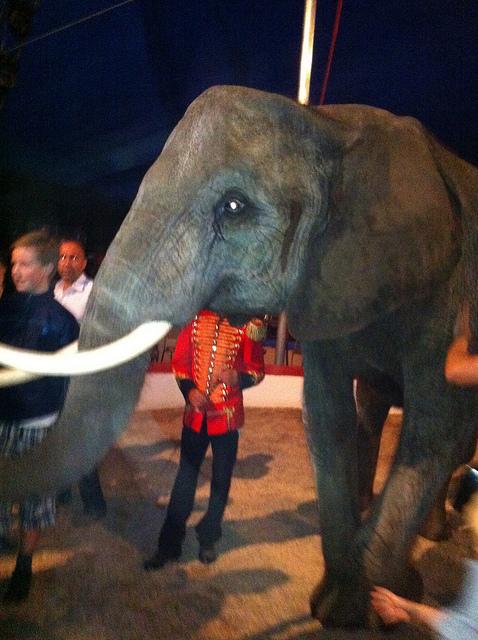Is the elephant indoors?
Write a very short answer. Yes. Is it night or day?
Short answer required. Night. How many elephant eyes can been seen?
Concise answer only. 1. Is this a circus?
Short answer required. Yes. 